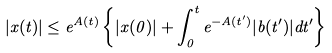<formula> <loc_0><loc_0><loc_500><loc_500>| x ( t ) | \leq e ^ { A ( t ) } \left \{ | x ( 0 ) | + \int _ { 0 } ^ { t } e ^ { - A ( t ^ { \prime } ) } | b ( t ^ { \prime } ) | d t ^ { \prime } \right \}</formula> 